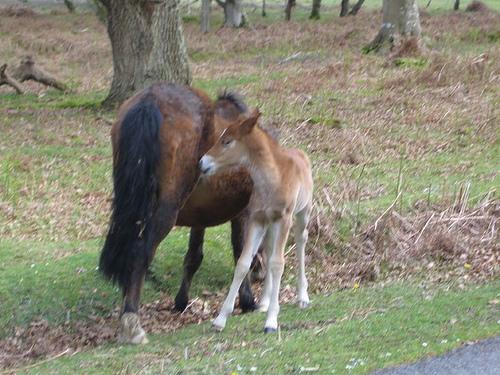What kind of fur does the adult have?
Short answer required. Brown. How many animals are there?
Concise answer only. 2. Is there a baby?
Write a very short answer. Yes. Is this an adult horse?
Keep it brief. Yes. Is the larger animal facing the picture?
Keep it brief. No. 